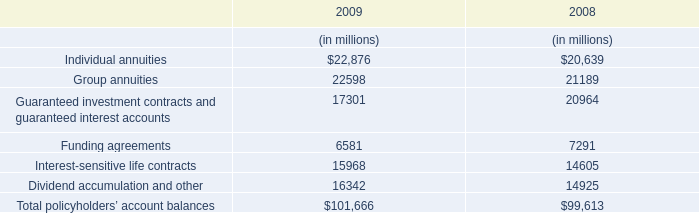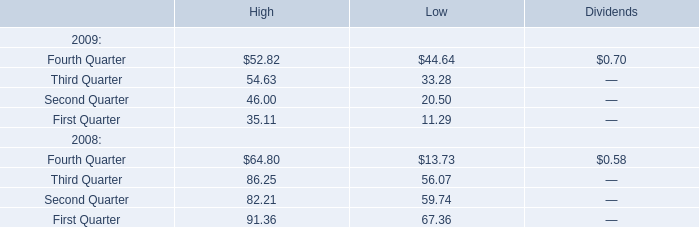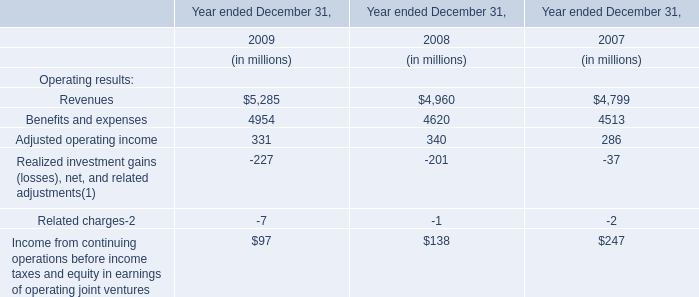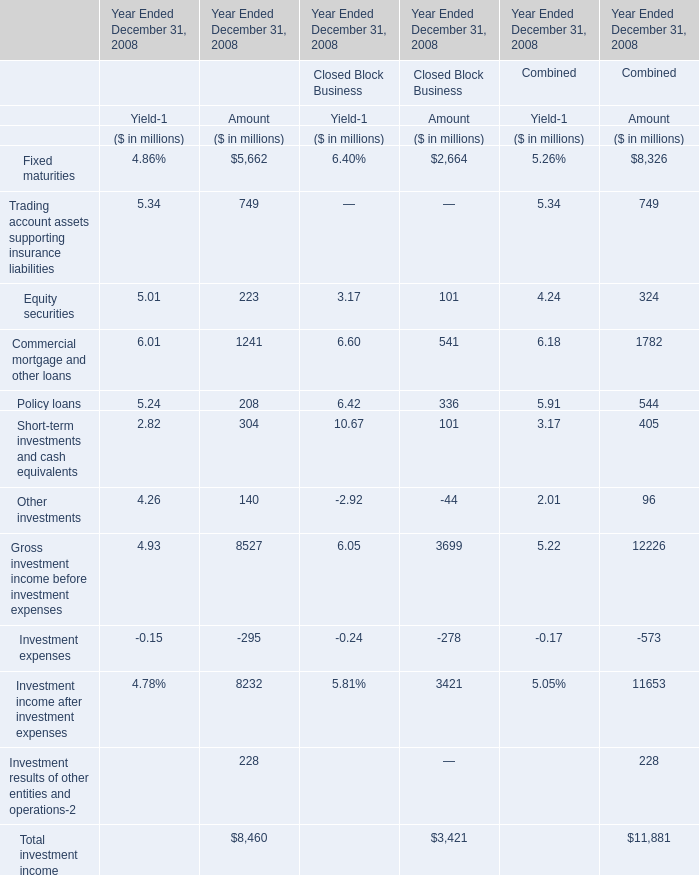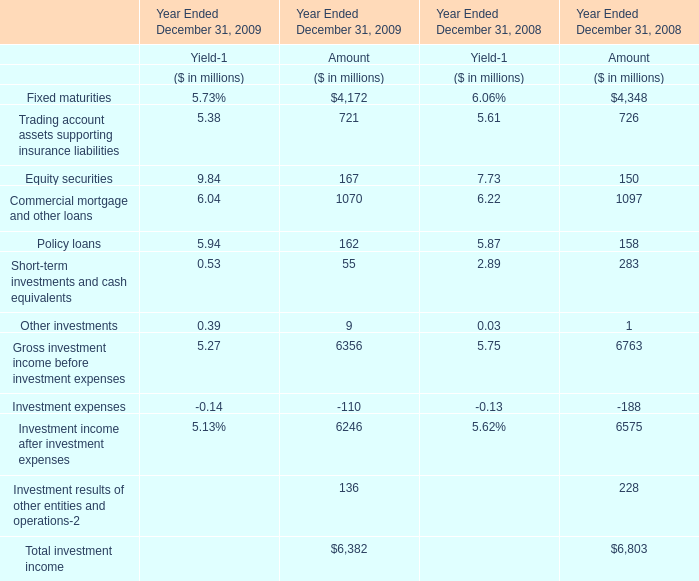In the year with largest amount of Policy loans for Amount , what's the increasing rate of Equity securities? 
Computations: ((167 - 150) / 150)
Answer: 0.11333. 